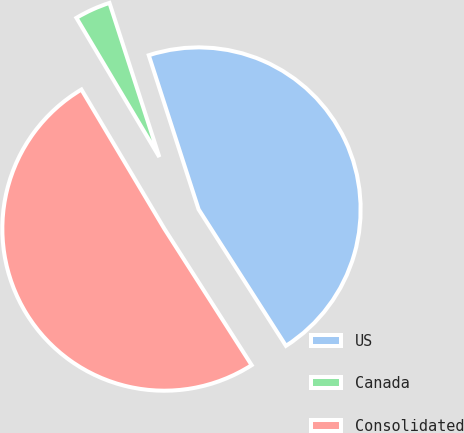<chart> <loc_0><loc_0><loc_500><loc_500><pie_chart><fcel>US<fcel>Canada<fcel>Consolidated<nl><fcel>45.92%<fcel>3.57%<fcel>50.51%<nl></chart> 